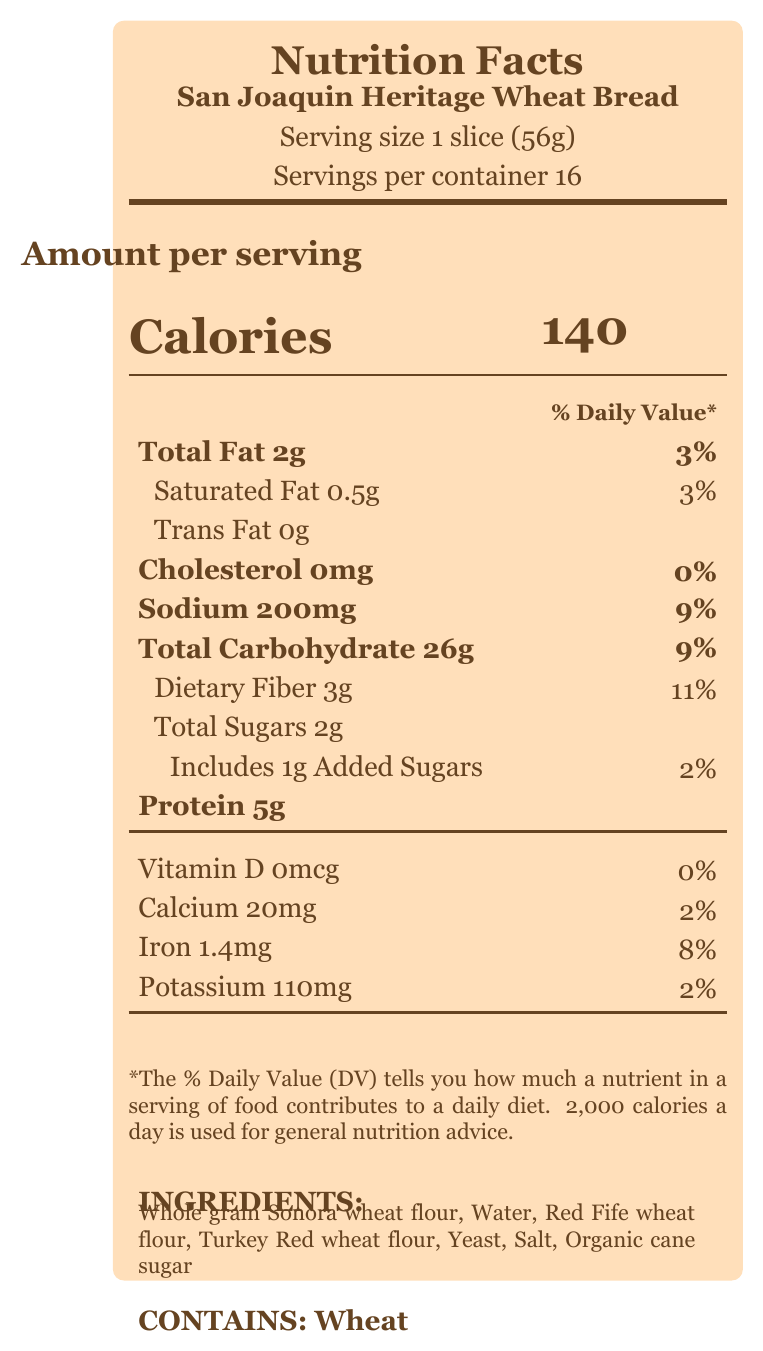what is the serving size for the San Joaquin Heritage Wheat Bread? The serving size is specified clearly on the document as "1 slice (56g)".
Answer: 1 slice (56g) how many servings are in one container of San Joaquin Heritage Wheat Bread? The document states that there are 16 servings per container.
Answer: 16 how many calories are in one serving of San Joaquin Heritage Wheat Bread? The number of calories per serving is listed as 140.
Answer: 140 how much total fat is there per serving? The total fat per serving is listed as 2g in the document.
Answer: 2g what percentage of the daily value is the dietary fiber in one serving? The dietary fiber has a daily value contribution of 11%, as shown in the document.
Answer: 11% how much iron does one serving provide? The document indicates that one serving provides 1.4mg of iron.
Answer: 1.4mg what are the main ingredients in San Joaquin Heritage Wheat Bread? The ingredients are clearly listed at the bottom of the document.
Answer: Whole grain Sonora wheat flour, Water, Red Fife wheat flour, Turkey Red wheat flour, Yeast, Salt, Organic cane sugar does the bread contain any cholesterol? The document lists 0mg of cholesterol per serving.
Answer: No how much sodium is in one slice of the bread? A. 150mg B. 200mg C. 250mg D. 300mg The document states that each slice contains 200mg of sodium.
Answer: B. 200mg what is the baking method for San Joaquin Heritage Wheat Bread? A. Traditional oven B. Stone-ground and naturally leavened C. Machine processed D. Microwave baked The document mentions that the bread is stone-ground and naturally leavened using traditional fermentation techniques.
Answer: B. Stone-ground and naturally leavened is there any added sugar in this bread? There is 1g of added sugars in the bread as reflected in the document.
Answer: Yes summarize the main nutritional benefits of San Joaquin Heritage Wheat Bread. The document mentions that the bread is rich in complex carbohydrates, fiber, and essential minerals such as iron and potassium.
Answer: Rich in complex carbohydrates, fiber, and essential minerals like iron and potassium what is the historical significance of the bread? This is mentioned in the additional information where it states the historical significance of using heritage grains from San Joaquin County.
Answer: Celebrates the agricultural heritage of San Joaquin County by using wheat varieties once commonly grown in the region. which wheat varieties are used in the bread? The document lists Whole grain Sonora wheat flour, Red Fife wheat flour, and Turkey Red wheat flour in its ingredients.
Answer: Sonora wheat, Red Fife wheat, Turkey Red wheat how many grams of protein does one serving contain? The document states that each serving contains 5g of protein.
Answer: 5g where are the heritage wheat varieties sourced from? This information is found in the additional info section regarding sourcing.
Answer: Local San Joaquin Valley farms committed to preserving agricultural biodiversity does the document provide the expiration date of the bread? The document does not mention anything about the expiration date.
Answer: No what percentage of daily value does the calcium provide per serving? The document mentions that calcium provides 2% of the daily value per serving.
Answer: 2% 